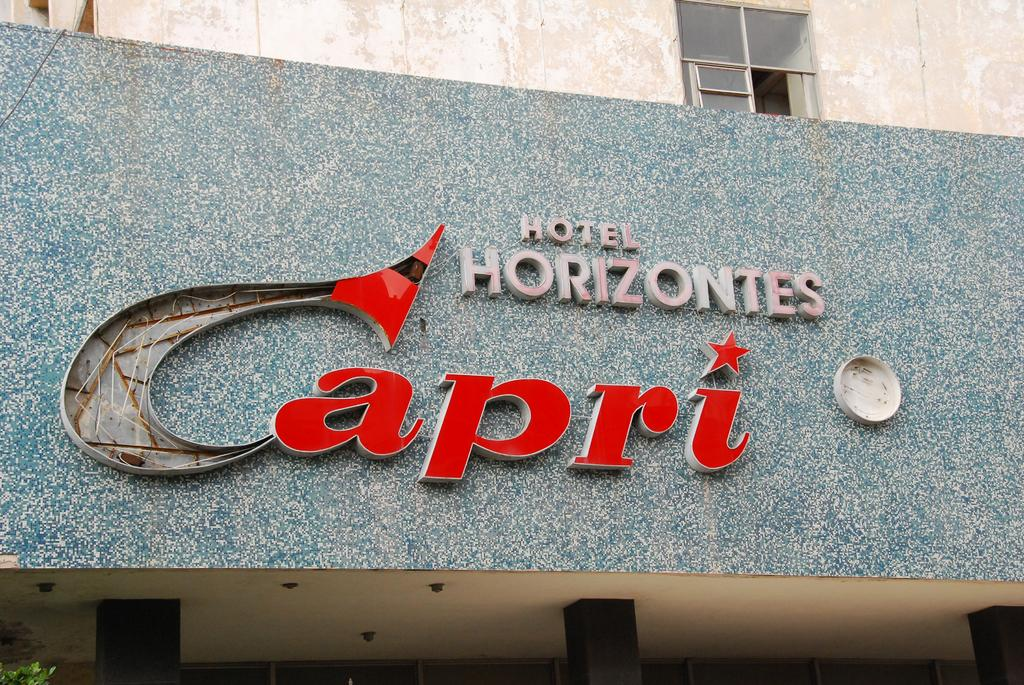<image>
Relay a brief, clear account of the picture shown. the outside of a building that is labeled as 'hotel horizontes capri' 